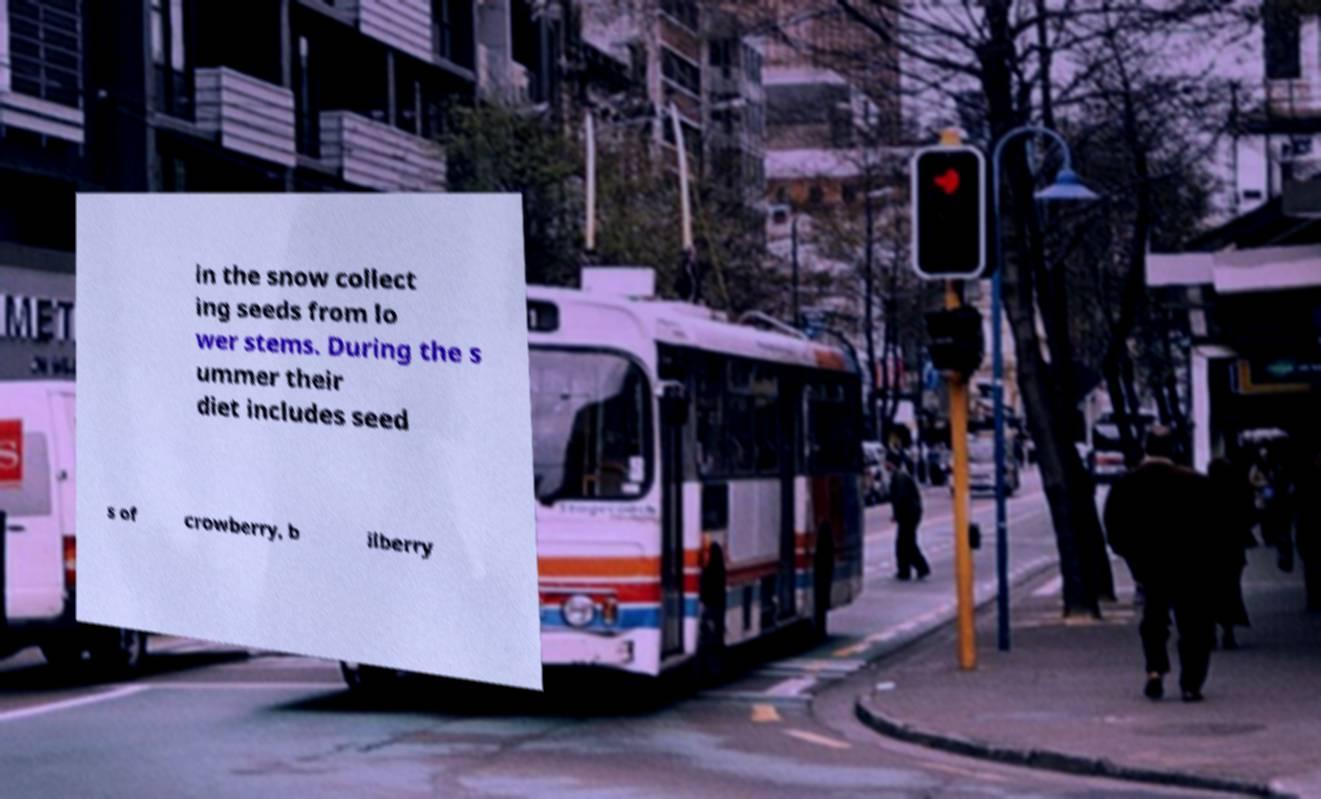There's text embedded in this image that I need extracted. Can you transcribe it verbatim? in the snow collect ing seeds from lo wer stems. During the s ummer their diet includes seed s of crowberry, b ilberry 